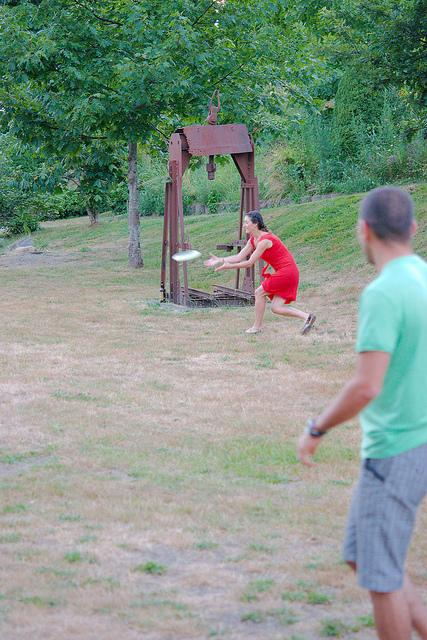What is the woman in red reaching towards?

Choices:
A) frisbee
B) cat
C) baby
D) dog frisbee 